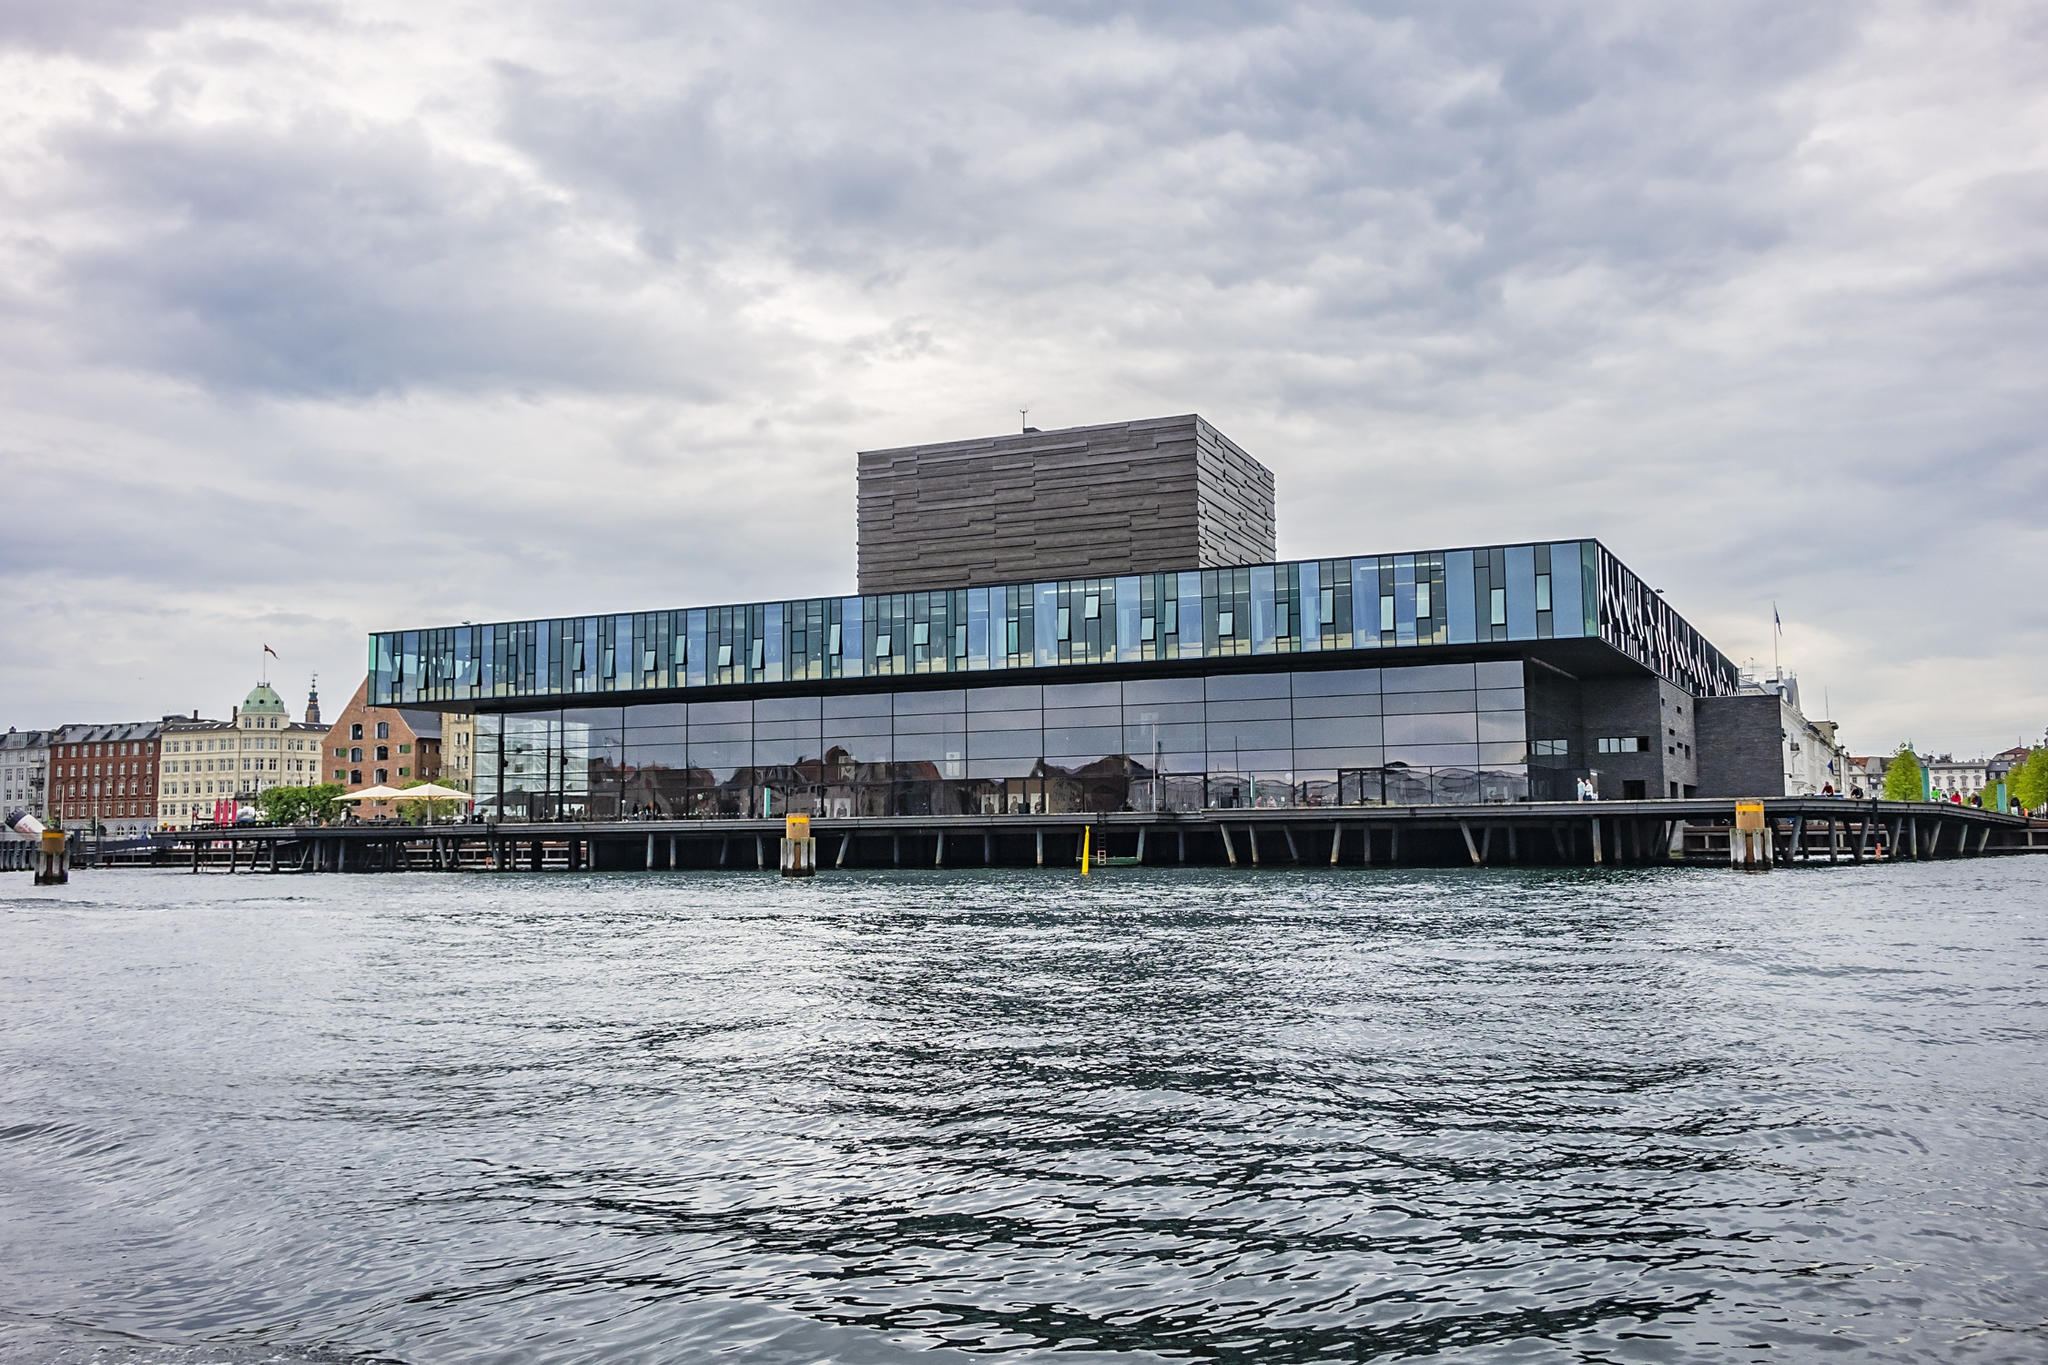Can you elaborate on the elements of the picture provided? The image captures the Royal Danish Playhouse in Copenhagen, Denmark, distinguished by its modern architecture. This waterfront structure features a stark, dark gray slate facade juxtaposed with expansive glass sections that reflect the cityscape and the waters it overlooks. The playhouse is not just a cultural landmark but also a brilliant representation of contemporary Nordic architecture, designed to blend public spaces with artistic venues. It's set against a backdrop of a cloudy sky and calm waters, creating a dynamic and inviting atmosphere. Discussing its architectural significance, the design underscores functionality and aesthetics, aiming to create an inclusive space for public engagement and theatrical performances. This setting not only enhances the city's cultural fabric but also attracts visitors with its scenic and urban harmony. 